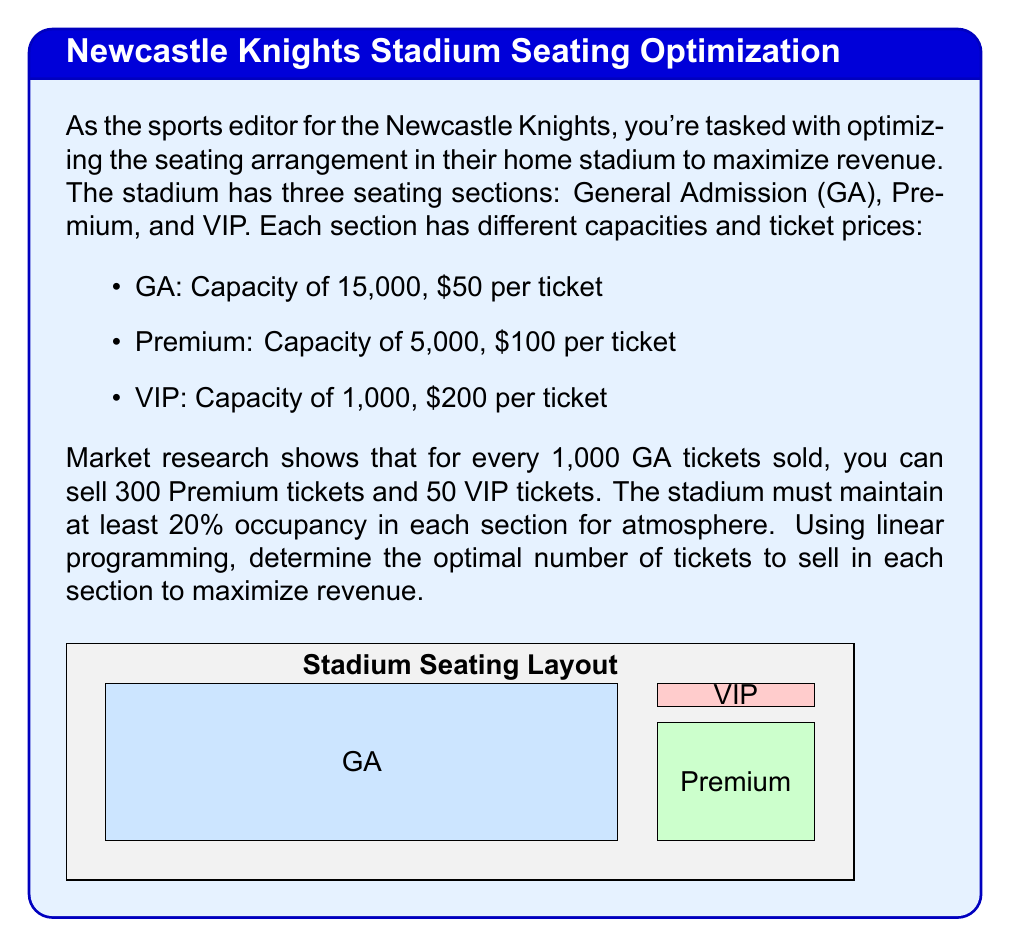Help me with this question. Let's approach this step-by-step using linear programming:

1) Define variables:
   Let $x$ = number of GA tickets sold (in thousands)
   Let $y$ = number of Premium tickets sold (in thousands)
   Let $z$ = number of VIP tickets sold (in thousands)

2) Objective function (maximize revenue):
   $$\text{Max } R = 50x + 100y + 200z$$

3) Constraints:
   a) Capacity constraints:
      $$x \leq 15$$
      $$y \leq 5$$
      $$z \leq 1$$

   b) Minimum occupancy constraints (20%):
      $$x \geq 3$$
      $$y \geq 1$$
      $$z \geq 0.2$$

   c) Market demand constraint:
      $$y = 0.3x$$
      $$z = 0.05x$$

4) Substitute the market demand constraints into the objective function:
   $$R = 50x + 100(0.3x) + 200(0.05x) = 50x + 30x + 10x = 90x$$

5) The problem reduces to maximizing $90x$ subject to:
   $$3 \leq x \leq 15$$
   $$0.3x \leq 5$$
   $$0.05x \geq 0.2$$

6) The binding constraint is $0.3x \leq 5$, which gives $x \leq 16.67$
   Given $x \leq 15$, the optimal solution is $x = 15$

7) Calculate $y$ and $z$:
   $$y = 0.3(15) = 4.5$$
   $$z = 0.05(15) = 0.75$$

8) The maximum revenue:
   $$R = 50(15) + 100(4.5) + 200(0.75) = 750 + 450 + 150 = 1350$$

Therefore, the optimal solution is to sell 15,000 GA tickets, 4,500 Premium tickets, and 750 VIP tickets, generating a revenue of $1,350,000.
Answer: GA: 15,000; Premium: 4,500; VIP: 750; Revenue: $1,350,000 